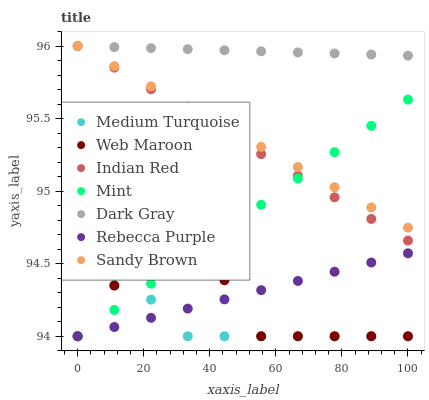Does Medium Turquoise have the minimum area under the curve?
Answer yes or no. Yes. Does Dark Gray have the maximum area under the curve?
Answer yes or no. Yes. Does Sandy Brown have the minimum area under the curve?
Answer yes or no. No. Does Sandy Brown have the maximum area under the curve?
Answer yes or no. No. Is Rebecca Purple the smoothest?
Answer yes or no. Yes. Is Web Maroon the roughest?
Answer yes or no. Yes. Is Sandy Brown the smoothest?
Answer yes or no. No. Is Sandy Brown the roughest?
Answer yes or no. No. Does Medium Turquoise have the lowest value?
Answer yes or no. Yes. Does Sandy Brown have the lowest value?
Answer yes or no. No. Does Indian Red have the highest value?
Answer yes or no. Yes. Does Web Maroon have the highest value?
Answer yes or no. No. Is Medium Turquoise less than Dark Gray?
Answer yes or no. Yes. Is Dark Gray greater than Rebecca Purple?
Answer yes or no. Yes. Does Sandy Brown intersect Indian Red?
Answer yes or no. Yes. Is Sandy Brown less than Indian Red?
Answer yes or no. No. Is Sandy Brown greater than Indian Red?
Answer yes or no. No. Does Medium Turquoise intersect Dark Gray?
Answer yes or no. No. 